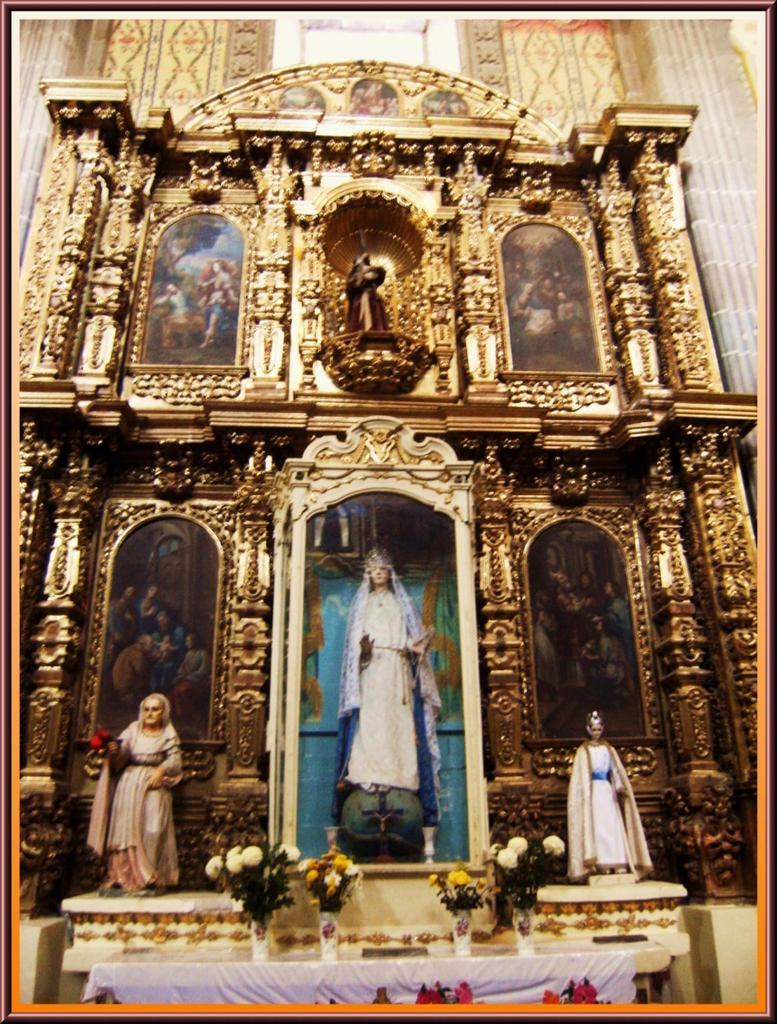What type of furniture is present in the image? There is a table in the image. What is placed on the table? There are flower vases on the table. What is the color or material of the wall in the image? There is a golden wall in the image. What decorations are on the golden wall? There are many paintings on the golden wall. How does the table stretch to accommodate more flower vases in the image? The table does not stretch in the image; it remains the same size. 